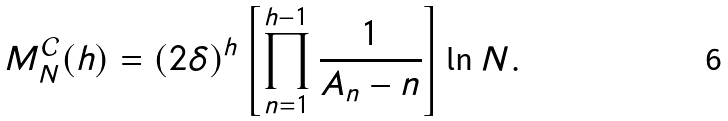<formula> <loc_0><loc_0><loc_500><loc_500>M _ { N } ^ { \mathcal { C } } ( h ) = ( 2 \delta ) ^ { h } \left [ \prod _ { n = 1 } ^ { h - 1 } \frac { 1 } { A _ { n } - n } \right ] \ln N .</formula> 